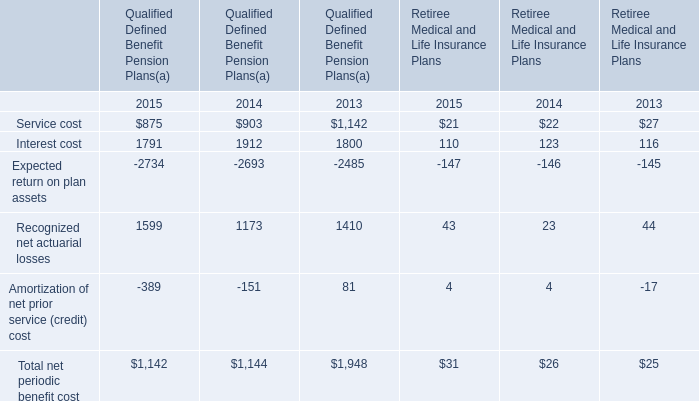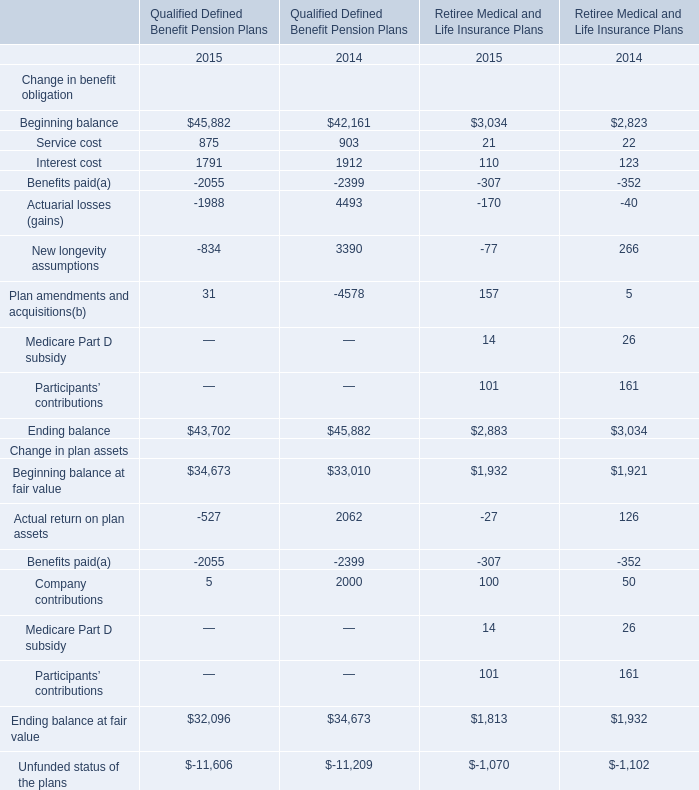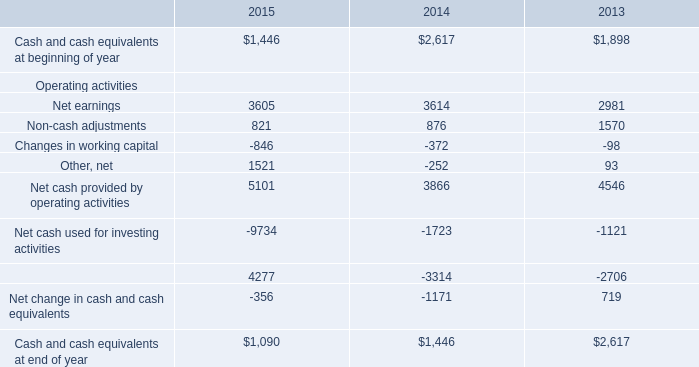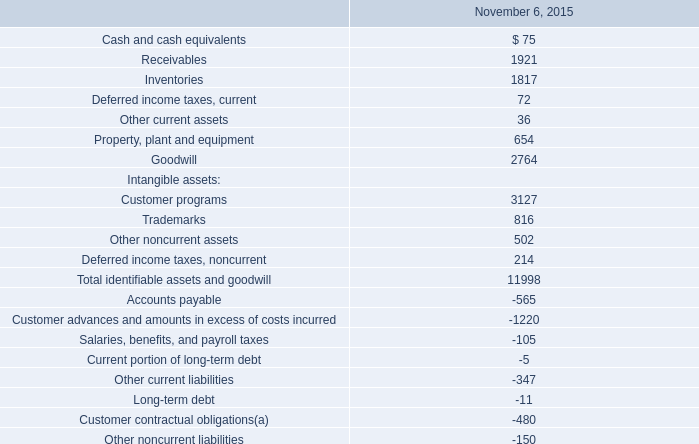In the year with the most Recognized net actuarial losses for Qualified Defined Benefit Pension Plans, what is the growth rate of Interest cost for Qualified Defined Benefit Pension Plans? 
Computations: ((1791 - 1912) / 1912)
Answer: -0.06328. Which year is Recognized net actuarial losses for Qualified Defined Benefit Pension Plans the most? 
Answer: 2015. 